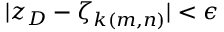<formula> <loc_0><loc_0><loc_500><loc_500>| z _ { D } - \zeta _ { k ( m , n ) } | < \epsilon</formula> 